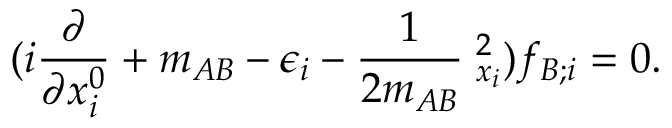Convert formula to latex. <formula><loc_0><loc_0><loc_500><loc_500>( i \frac { \partial } { \partial x _ { i } ^ { 0 } } + m _ { A B } - \epsilon _ { i } - \frac { 1 } { 2 m _ { A B } } { \nabla } _ { x _ { i } } ^ { 2 } ) f _ { B ; i } = 0 .</formula> 